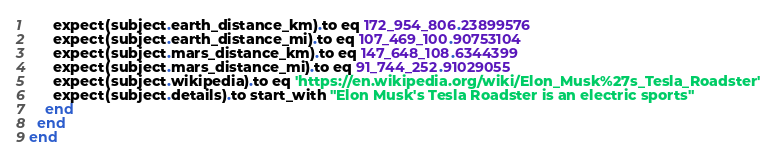Convert code to text. <code><loc_0><loc_0><loc_500><loc_500><_Ruby_>      expect(subject.earth_distance_km).to eq 172_954_806.23899576
      expect(subject.earth_distance_mi).to eq 107_469_100.90753104
      expect(subject.mars_distance_km).to eq 147_648_108.6344399
      expect(subject.mars_distance_mi).to eq 91_744_252.91029055
      expect(subject.wikipedia).to eq 'https://en.wikipedia.org/wiki/Elon_Musk%27s_Tesla_Roadster'
      expect(subject.details).to start_with "Elon Musk's Tesla Roadster is an electric sports"
    end
  end
end
</code> 